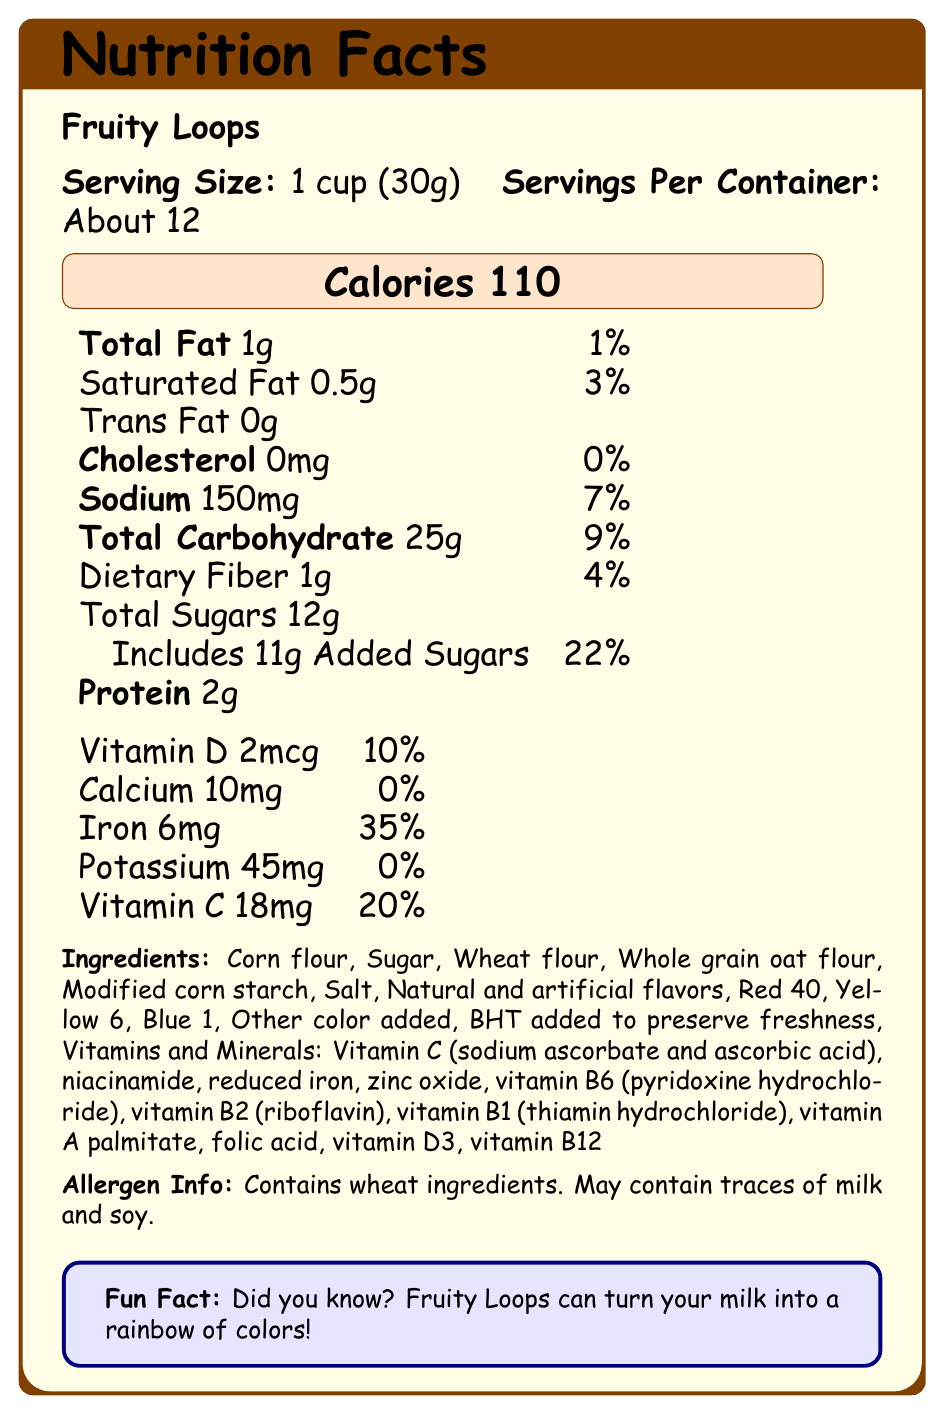What is the serving size of Fruity Loops? The serving size is clearly listed as "1 cup (30g)" on the document.
Answer: 1 cup (30g) How many calories are in one serving of Fruity Loops? The calories per serving are displayed prominently in a highlighted box as "Calories 110".
Answer: 110 calories What is the total fat content per serving? The total fat content is listed as "1g", which can be found in the nutritional summary under "Total Fat".
Answer: 1g How much sodium does one serving of Fruity Loops contain? The sodium content is listed alongside its daily value percentage and is "150mg".
Answer: 150mg What percentage of the daily value of iron does one serving provide? The document states that one serving provides 35% of the daily value of iron.
Answer: 35% Does Fruity Loops contain any cholesterol? The document shows that Fruity Loops contains 0mg of cholesterol, indicating it does not contain any cholesterol.
Answer: No What colors can you find in Fruity Loops cereal shapes? A. Red, Yellow, Blue B. Red, Yellow, Blue, Green, Orange, Purple C. Green, Blue, Purple, Orange, Yellow The document explicitly lists the colors of the cereal shapes: Red, Yellow, Blue, Green, Orange, Purple.
Answer: B Which of the following is NOT an ingredient in Fruity Loops? I. Corn flour II. Sunflower oil III. BHT IV. Vitamin C The listed ingredients do not include sunflower oil. The ingredients are "Corn flour", "Sugar", "Wheat flour", "Whole grain oat flour", "Modified corn starch", "Salt", "Natural and artificial flavors", "Red 40", "Yellow 6", "Blue 1", "Other color added", "BHT added to preserve freshness", "Vitamins and Minerals: Vitamin C (sodium ascorbate and ascorbic acid), niacinamide, reduced iron, zinc oxide, vitamin B6 (pyridoxine hydrochloride), vitamin B2 (riboflavin), vitamin B1 (thiamin hydrochloride), vitamin A palmitate, folic acid, vitamin D3, vitamin B12".
Answer: II. Sunflower oil Does Fruity Loops contain any added sugars? The document shows that Fruity Loops contains 11g of added sugars.
Answer: Yes Is there any dietary fiber in Fruity Loops? The nutritional facts list 1g of dietary fiber per serving.
Answer: Yes Does Fruity Loops contain traces of soy? The allergen information states that Fruity Loops may contain traces of milk and soy.
Answer: It is possible Do Fruity Loops have the ability to turn milk a different color? The fun fact in the document mentions that Fruity Loops can turn your milk into a rainbow of colors.
Answer: Yes Are there any natural flavors in Fruity Loops? The ingredients list includes "Natural and artificial flavors".
Answer: Yes Summarize the main nutritional highlights of Fruity Loops. The summary includes key nutritional facts, such as calories, fat, sodium, carbohydrates, proteins, and vitamins, as well as some fun facts about the cereal.
Answer: Fruity Loops is a breakfast cereal with a serving size of 1 cup (30g), which provides 110 calories per serving. It contains 1g of total fat, 150mg of sodium, 25g of total carbohydrates including 12g of total sugars and 11g of added sugars, and 2g of protein. Additionally, it offers various vitamins and minerals, including 35% of the daily value of iron and 20% of vitamin C. The cereal comes in colorful shapes and can turn milk into a rainbow of colors. What are the colors of the background in the document? The document does not visually display the colors of the background; it only mentions "Tropical jungle scene" in the text.
Answer: Cannot be determined 